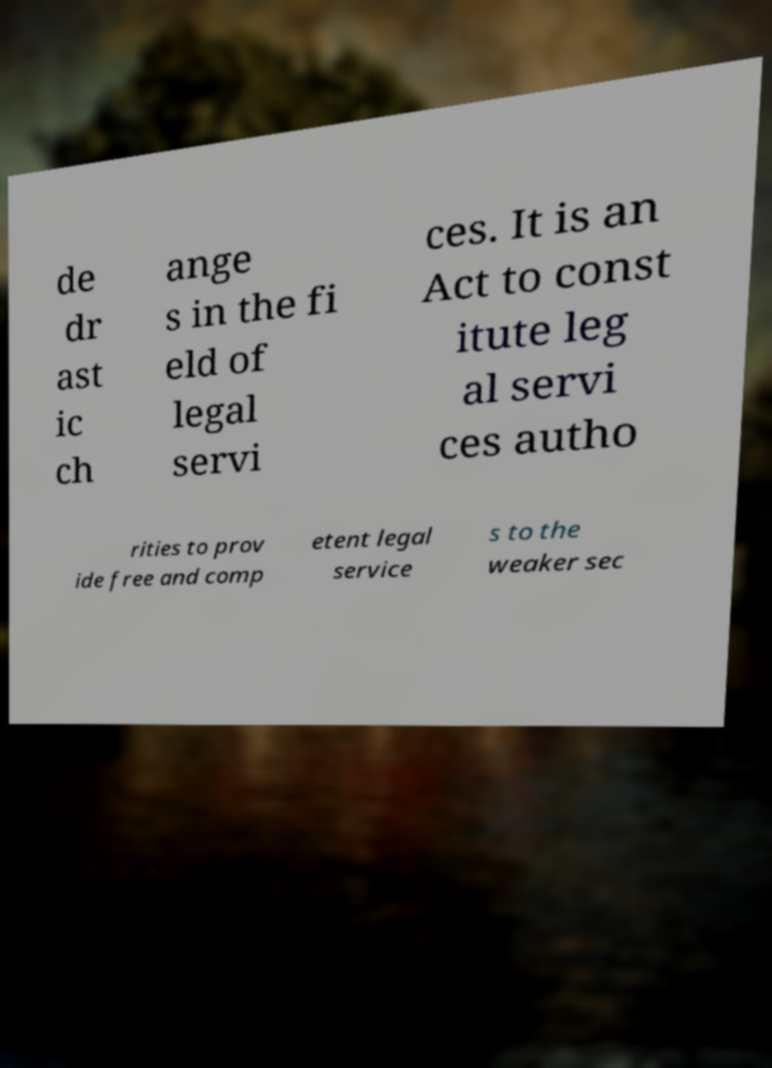I need the written content from this picture converted into text. Can you do that? de dr ast ic ch ange s in the fi eld of legal servi ces. It is an Act to const itute leg al servi ces autho rities to prov ide free and comp etent legal service s to the weaker sec 